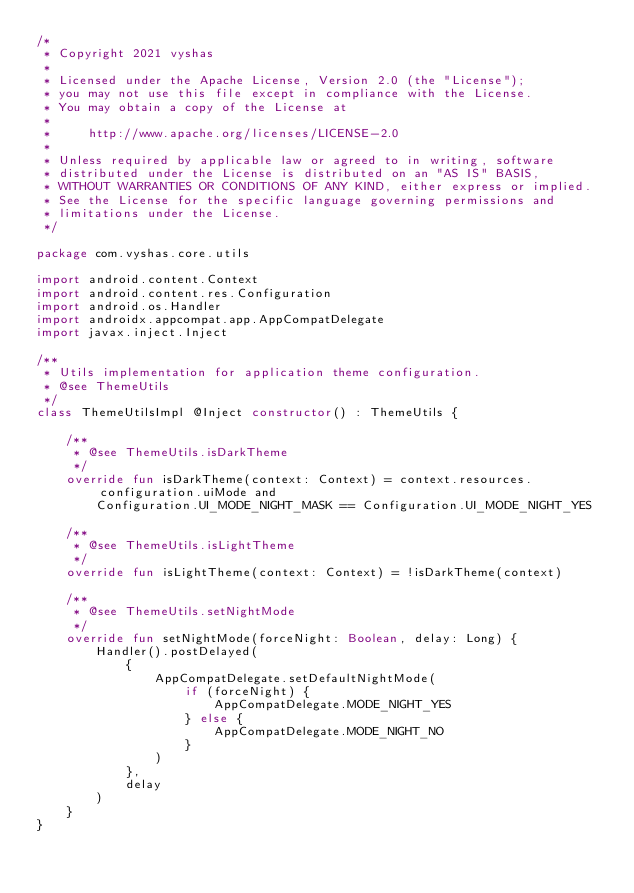<code> <loc_0><loc_0><loc_500><loc_500><_Kotlin_>/*
 * Copyright 2021 vyshas
 *
 * Licensed under the Apache License, Version 2.0 (the "License");
 * you may not use this file except in compliance with the License.
 * You may obtain a copy of the License at
 *
 *     http://www.apache.org/licenses/LICENSE-2.0
 *
 * Unless required by applicable law or agreed to in writing, software
 * distributed under the License is distributed on an "AS IS" BASIS,
 * WITHOUT WARRANTIES OR CONDITIONS OF ANY KIND, either express or implied.
 * See the License for the specific language governing permissions and
 * limitations under the License.
 */

package com.vyshas.core.utils

import android.content.Context
import android.content.res.Configuration
import android.os.Handler
import androidx.appcompat.app.AppCompatDelegate
import javax.inject.Inject

/**
 * Utils implementation for application theme configuration.
 * @see ThemeUtils
 */
class ThemeUtilsImpl @Inject constructor() : ThemeUtils {

    /**
     * @see ThemeUtils.isDarkTheme
     */
    override fun isDarkTheme(context: Context) = context.resources.configuration.uiMode and
        Configuration.UI_MODE_NIGHT_MASK == Configuration.UI_MODE_NIGHT_YES

    /**
     * @see ThemeUtils.isLightTheme
     */
    override fun isLightTheme(context: Context) = !isDarkTheme(context)

    /**
     * @see ThemeUtils.setNightMode
     */
    override fun setNightMode(forceNight: Boolean, delay: Long) {
        Handler().postDelayed(
            {
                AppCompatDelegate.setDefaultNightMode(
                    if (forceNight) {
                        AppCompatDelegate.MODE_NIGHT_YES
                    } else {
                        AppCompatDelegate.MODE_NIGHT_NO
                    }
                )
            },
            delay
        )
    }
}
</code> 